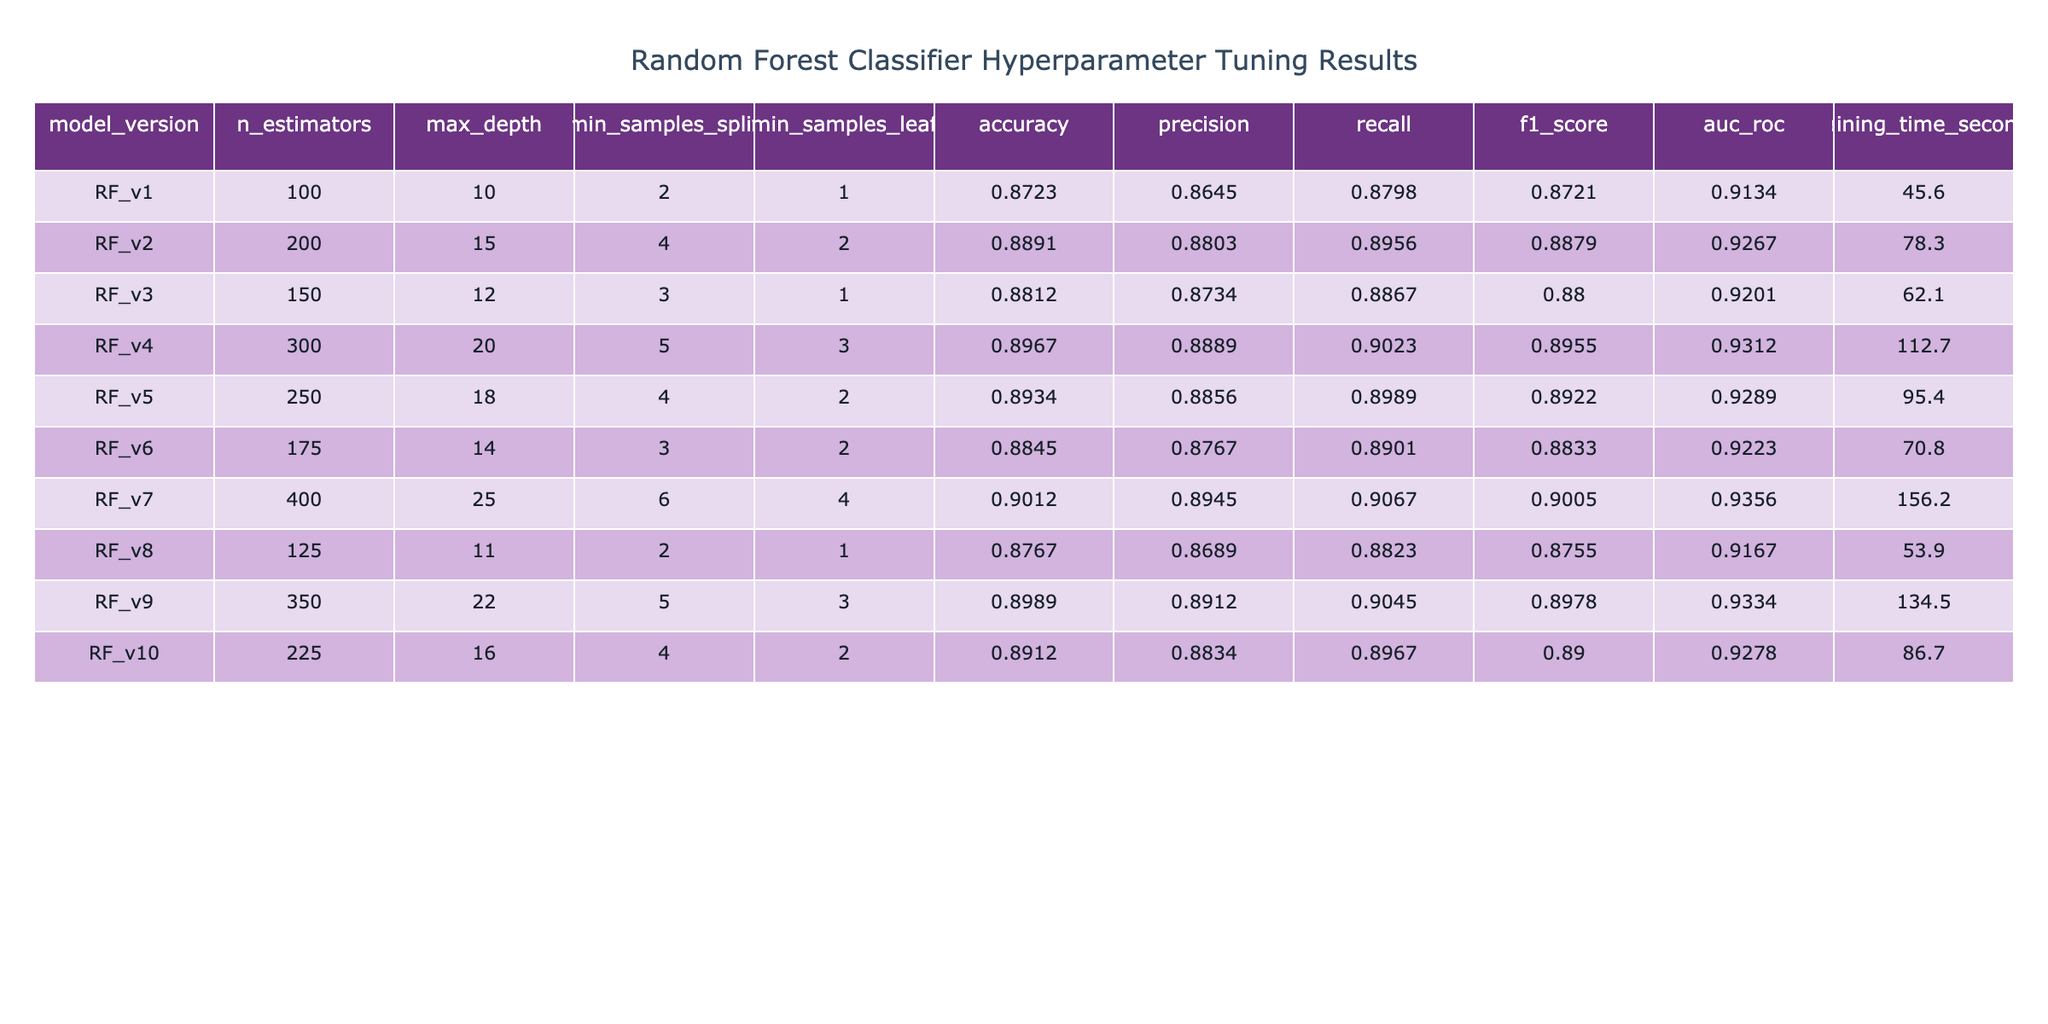What is the accuracy of the model RF_v4? According to the table, the accuracy value for model RF_v4 is provided in the corresponding row under the accuracy column. It is 0.8967.
Answer: 0.8967 Which model has the highest f1_score? To determine the highest f1_score, we can compare the f1_score values of all models listed in the table. The highest value is found in model RF_v7, which has an f1_score of 0.9005.
Answer: RF_v7 What is the average training time of all models? We can calculate the average training time by summing the training times for all models and dividing by the number of models. The sum of training times is (45.6 + 78.3 + 62.1 + 112.7 + 95.4 + 70.8 + 156.2 + 53.9 + 134.5 + 86.7) = 800.2 seconds, and there are 10 models, so the average training time is 800.2 / 10 = 80.02 seconds.
Answer: 80.02 seconds Is the precision for RF_v9 greater than 0.89? The precision for model RF_v9 is 0.8912, which is indeed greater than 0.89. Therefore, the statement is true.
Answer: Yes What is the difference in accuracy between RF_v7 and RF_v6? First, we find the accuracy of RF_v7, which is 0.9012, and the accuracy of RF_v6, which is 0.8845. The difference is 0.9012 - 0.8845 = 0.0167.
Answer: 0.0167 Which model has the largest number of estimators, and what is its accuracy? Checking the n_estimators column, model RF_v7 has the largest number of estimators at 400. Its accuracy is 0.9012 as per the corresponding row.
Answer: RF_v7, 0.9012 Does increasing the max_depth always lead to an increase in accuracy? A review of the accuracy alongside max_depth shows various outcomes; for example, increasing max_depth from 10 (RF_v1, accuracy 0.8723) to 15 (RF_v2, accuracy 0.8891) improves accuracy, but then increasing to 20 (RF_v4, accuracy 0.8967) further improves it, yet other models with higher depths (RF_v9 with 22 and RF_v7 with 25) do not always show consistent increases. Thus, it is not always true that accuracy increases.
Answer: No What is the total AUC-ROC for RF_v3 and RF_v6 combined? The AUC-ROC for RF_v3 is 0.9201, and for RF_v6 it is 0.9223. Summing these values gives: 0.9201 + 0.9223 = 1.8424.
Answer: 1.8424 Which two models have an accuracy above 0.89? Scanning through the accuracy column, models RF_v2 (0.8891), RF_v4 (0.8967), RF_v5 (0.8934), RF_v7 (0.9012), and RF_v9 (0.8989) all exceed 0.89. The two models with the highest accuracy above this threshold are RF_v4 (0.8967) and RF_v7 (0.9012).
Answer: RF_v4 and RF_v7 